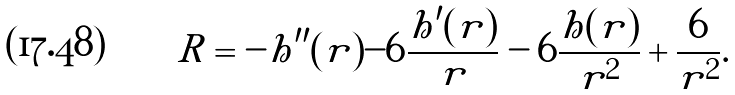<formula> <loc_0><loc_0><loc_500><loc_500>R = - h ^ { \prime \prime } ( r ) - 6 \frac { h ^ { \prime } ( r ) } { r } - 6 \frac { h ( r ) } { r ^ { 2 } } + \frac { 6 } { r ^ { 2 } } .</formula> 